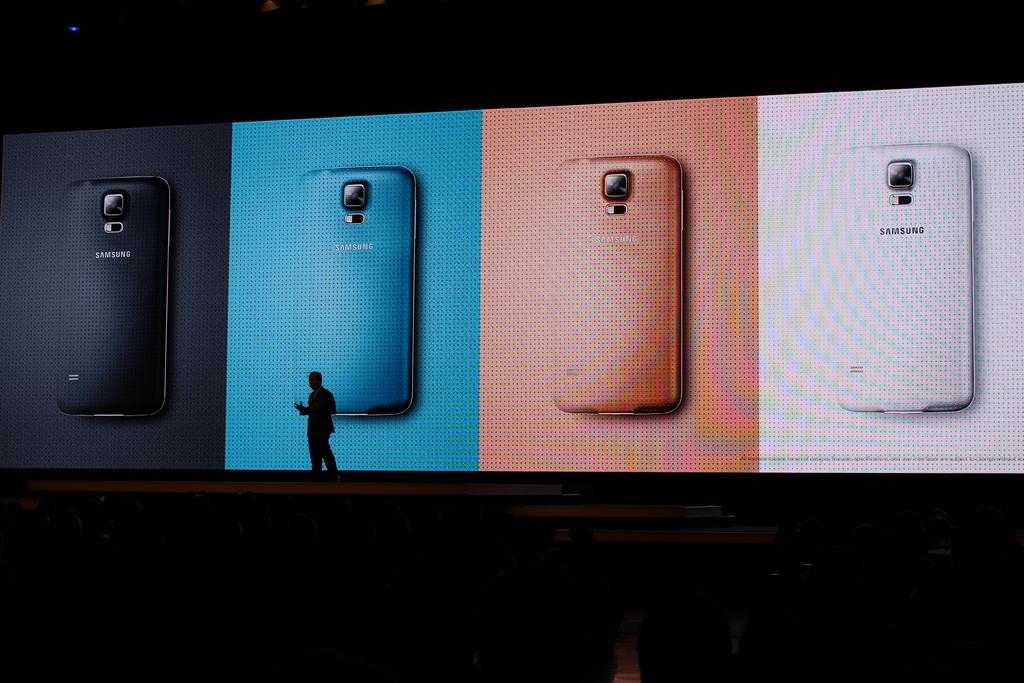What is the man in the image doing? The man is standing on a stage in the image. What is behind the man on the stage? There is a big screen behind the man. Can you describe the lighting in the image? There is a light at the top of the image. What type of pancake is being flipped on the stage in the image? There is no pancake present in the image; the man is standing on a stage with a big screen behind him and a light at the top of the image. 